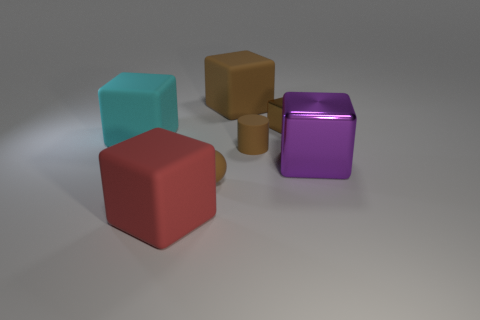What number of other objects are there of the same shape as the big cyan rubber thing?
Provide a succinct answer. 4. Are there any large blocks that are behind the metallic object behind the purple thing?
Your answer should be compact. Yes. What number of large cubes are there?
Offer a terse response. 4. Do the small cube and the tiny rubber object that is in front of the purple object have the same color?
Your answer should be very brief. Yes. Is the number of cyan rubber blocks greater than the number of shiny blocks?
Ensure brevity in your answer.  No. Is there any other thing that has the same color as the ball?
Provide a short and direct response. Yes. What number of other objects are there of the same size as the purple metal thing?
Your answer should be very brief. 3. The brown object in front of the shiny cube that is on the right side of the small brown thing that is behind the cyan matte block is made of what material?
Ensure brevity in your answer.  Rubber. Do the large red cube and the large cube behind the large cyan object have the same material?
Your answer should be compact. Yes. Is the number of large matte blocks in front of the small matte ball less than the number of big things that are behind the large shiny cube?
Give a very brief answer. Yes. 